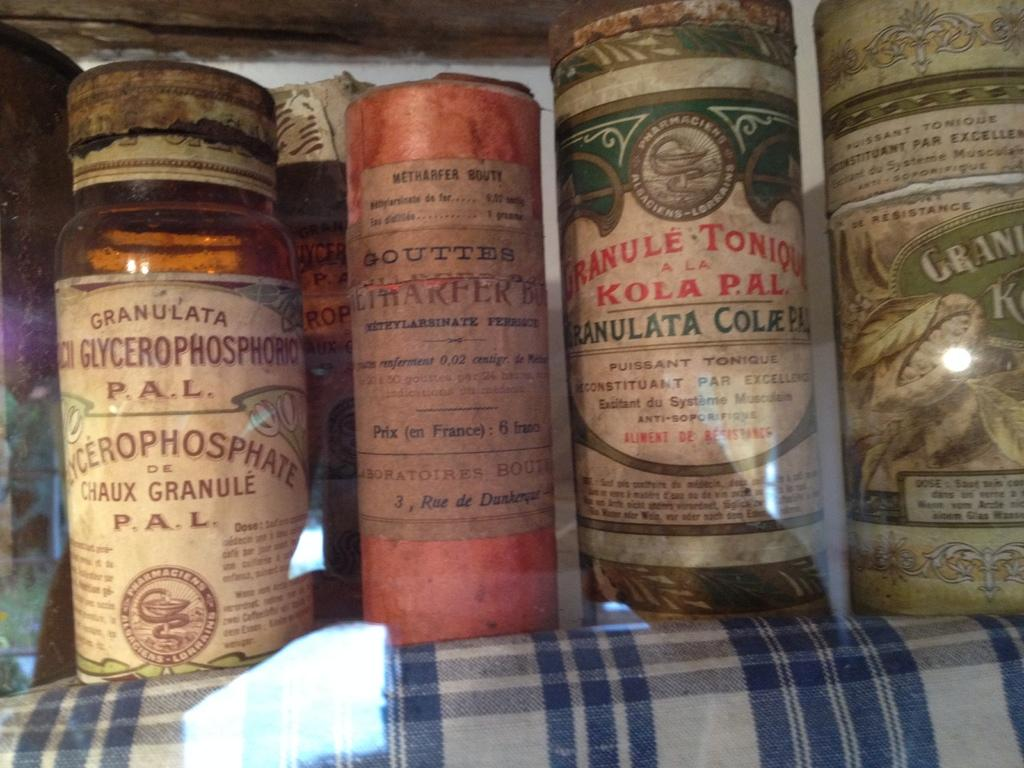<image>
Relay a brief, clear account of the picture shown. candles standing next to one another with one of htme labeled 'kola pal' 